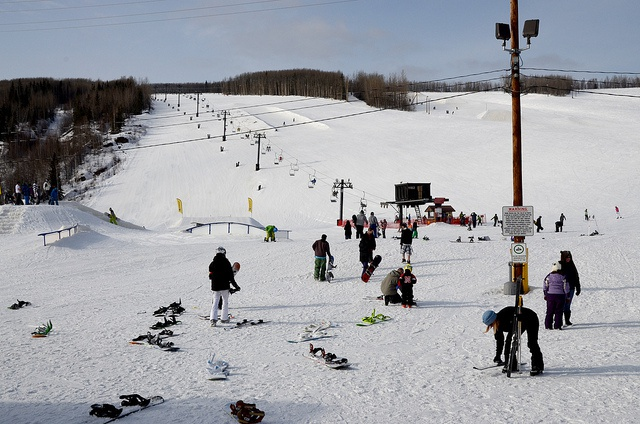Describe the objects in this image and their specific colors. I can see people in darkgray, lightgray, black, and gray tones, people in darkgray, black, gray, and lightgray tones, people in darkgray, black, lightgray, and gray tones, snowboard in darkgray, lightgray, black, and gray tones, and people in darkgray, black, purple, and navy tones in this image. 